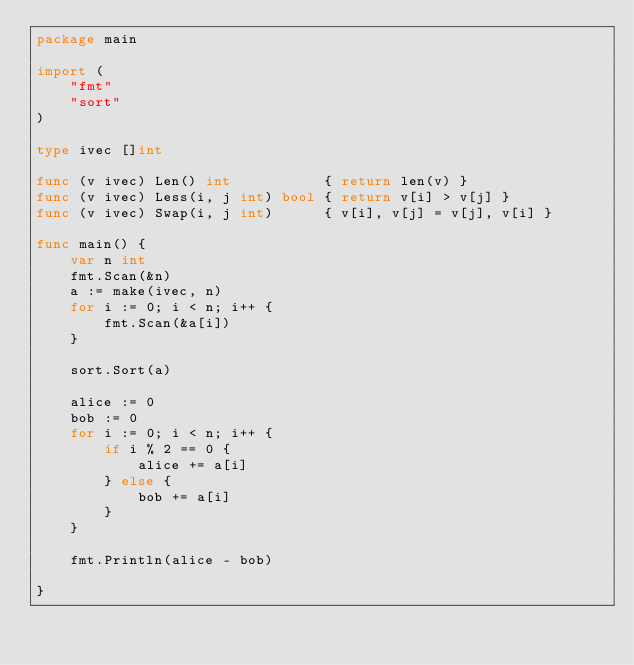<code> <loc_0><loc_0><loc_500><loc_500><_Go_>package main
 
import (
	"fmt"
	"sort"
)
 
type ivec []int
 
func (v ivec) Len() int           { return len(v) }
func (v ivec) Less(i, j int) bool { return v[i] > v[j] }
func (v ivec) Swap(i, j int)      { v[i], v[j] = v[j], v[i] }
 
func main() {
	var n int
	fmt.Scan(&n)
	a := make(ivec, n)
	for i := 0; i < n; i++ {
		fmt.Scan(&a[i])
	}
 
	sort.Sort(a)
 
	alice := 0
	bob := 0
	for i := 0; i < n; i++ {
		if i % 2 == 0 {
			alice += a[i]
		} else {
			bob += a[i]
		}
	}
 
	fmt.Println(alice - bob)
 
}
</code> 